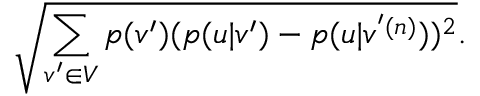<formula> <loc_0><loc_0><loc_500><loc_500>\sqrt { \sum _ { v ^ { \prime } \in V } p ( v ^ { \prime } ) ( p ( u | v ^ { \prime } ) - p ( u | v ^ { ^ { \prime } ( n ) } ) ) ^ { 2 } } .</formula> 